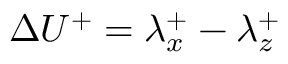Convert formula to latex. <formula><loc_0><loc_0><loc_500><loc_500>\Delta U ^ { + } = \lambda _ { x } ^ { + } - \lambda _ { z } ^ { + }</formula> 